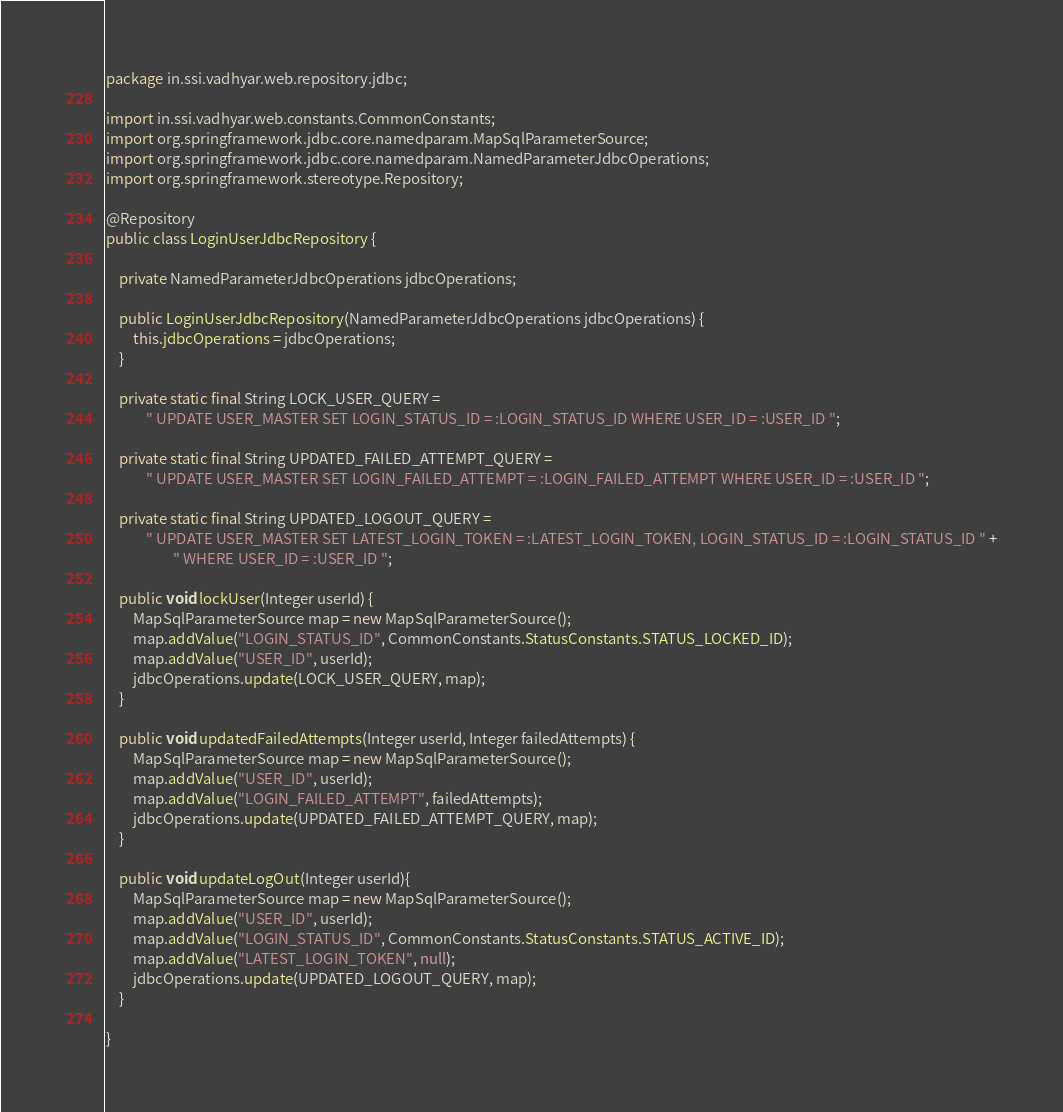Convert code to text. <code><loc_0><loc_0><loc_500><loc_500><_Java_>package in.ssi.vadhyar.web.repository.jdbc;

import in.ssi.vadhyar.web.constants.CommonConstants;
import org.springframework.jdbc.core.namedparam.MapSqlParameterSource;
import org.springframework.jdbc.core.namedparam.NamedParameterJdbcOperations;
import org.springframework.stereotype.Repository;

@Repository
public class LoginUserJdbcRepository {

    private NamedParameterJdbcOperations jdbcOperations;

    public LoginUserJdbcRepository(NamedParameterJdbcOperations jdbcOperations) {
        this.jdbcOperations = jdbcOperations;
    }

    private static final String LOCK_USER_QUERY =
            " UPDATE USER_MASTER SET LOGIN_STATUS_ID = :LOGIN_STATUS_ID WHERE USER_ID = :USER_ID ";

    private static final String UPDATED_FAILED_ATTEMPT_QUERY =
            " UPDATE USER_MASTER SET LOGIN_FAILED_ATTEMPT = :LOGIN_FAILED_ATTEMPT WHERE USER_ID = :USER_ID ";

    private static final String UPDATED_LOGOUT_QUERY =
            " UPDATE USER_MASTER SET LATEST_LOGIN_TOKEN = :LATEST_LOGIN_TOKEN, LOGIN_STATUS_ID = :LOGIN_STATUS_ID " +
                    " WHERE USER_ID = :USER_ID ";

    public void lockUser(Integer userId) {
        MapSqlParameterSource map = new MapSqlParameterSource();
        map.addValue("LOGIN_STATUS_ID", CommonConstants.StatusConstants.STATUS_LOCKED_ID);
        map.addValue("USER_ID", userId);
        jdbcOperations.update(LOCK_USER_QUERY, map);
    }

    public void updatedFailedAttempts(Integer userId, Integer failedAttempts) {
        MapSqlParameterSource map = new MapSqlParameterSource();
        map.addValue("USER_ID", userId);
        map.addValue("LOGIN_FAILED_ATTEMPT", failedAttempts);
        jdbcOperations.update(UPDATED_FAILED_ATTEMPT_QUERY, map);
    }

    public void updateLogOut(Integer userId){
        MapSqlParameterSource map = new MapSqlParameterSource();
        map.addValue("USER_ID", userId);
        map.addValue("LOGIN_STATUS_ID", CommonConstants.StatusConstants.STATUS_ACTIVE_ID);
        map.addValue("LATEST_LOGIN_TOKEN", null);
        jdbcOperations.update(UPDATED_LOGOUT_QUERY, map);
    }

}
</code> 